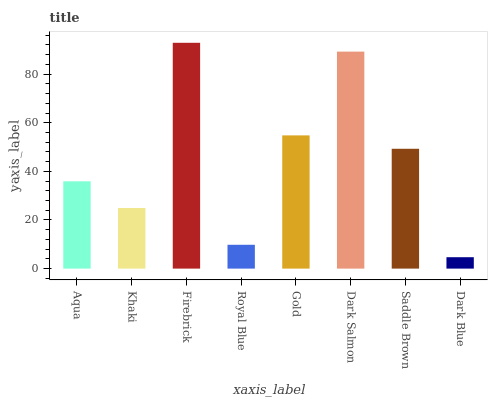Is Dark Blue the minimum?
Answer yes or no. Yes. Is Firebrick the maximum?
Answer yes or no. Yes. Is Khaki the minimum?
Answer yes or no. No. Is Khaki the maximum?
Answer yes or no. No. Is Aqua greater than Khaki?
Answer yes or no. Yes. Is Khaki less than Aqua?
Answer yes or no. Yes. Is Khaki greater than Aqua?
Answer yes or no. No. Is Aqua less than Khaki?
Answer yes or no. No. Is Saddle Brown the high median?
Answer yes or no. Yes. Is Aqua the low median?
Answer yes or no. Yes. Is Dark Salmon the high median?
Answer yes or no. No. Is Royal Blue the low median?
Answer yes or no. No. 